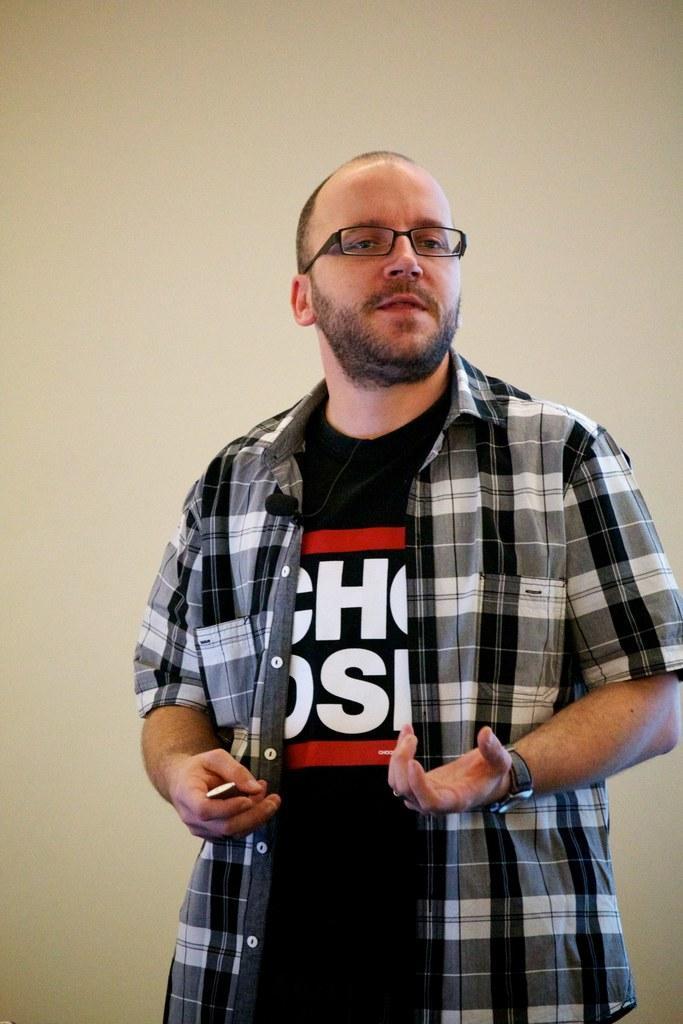Describe this image in one or two sentences. In this image there is a man standing. He is wearing a watch and spectacles. There is a mic to his shirt. Behind him there is a wall. 